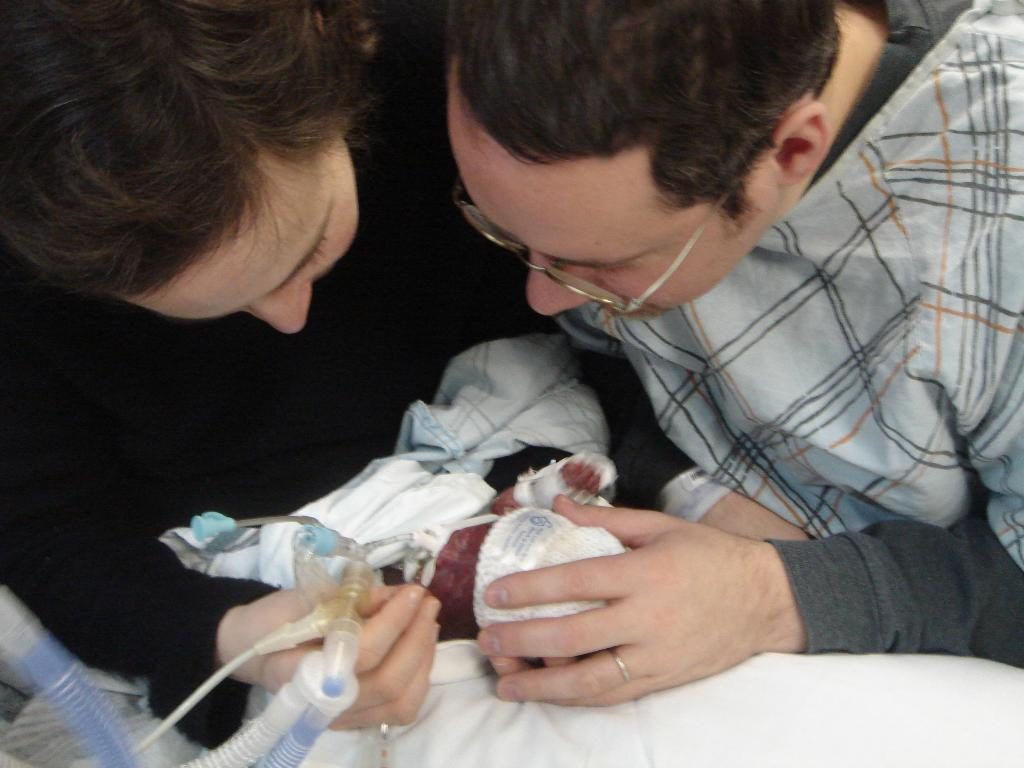How many people are in the image? There are two persons in the image. What are the two persons doing? The two persons are looking at a baby. Can you identify any medical equipment in the image? Yes, there appears to be an oxygen supply pipe on the bottom left side of the image. What type of loaf is being served on the table in the image? There is no table or loaf present in the image. Can you describe the rest provided for the baby in the image? There is no mention of a baby's rest in the image; the focus is on the two persons looking at the baby and the presence of an oxygen supply pipe. 